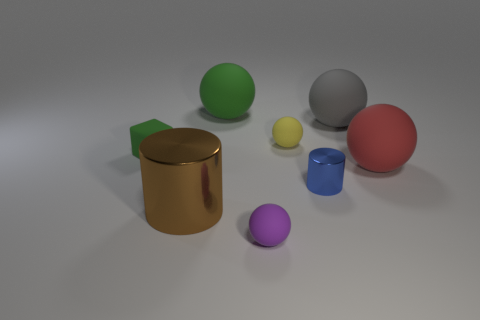Subtract all gray matte balls. How many balls are left? 4 Subtract all gray spheres. How many spheres are left? 4 Subtract all brown spheres. Subtract all cyan cylinders. How many spheres are left? 5 Add 2 small blue metallic objects. How many objects exist? 10 Subtract all balls. How many objects are left? 3 Add 2 large cylinders. How many large cylinders are left? 3 Add 7 small cylinders. How many small cylinders exist? 8 Subtract 0 blue blocks. How many objects are left? 8 Subtract all gray shiny cubes. Subtract all small yellow rubber things. How many objects are left? 7 